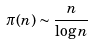<formula> <loc_0><loc_0><loc_500><loc_500>\pi ( n ) \sim \frac { n } { \log n }</formula> 